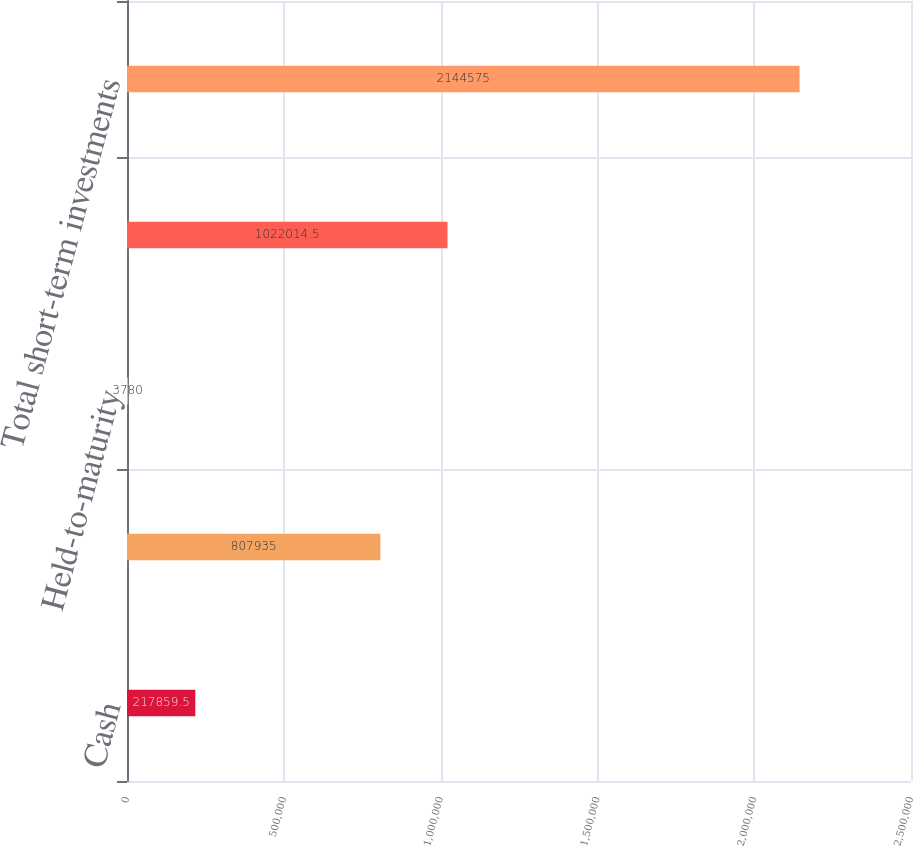Convert chart. <chart><loc_0><loc_0><loc_500><loc_500><bar_chart><fcel>Cash<fcel>Available-for-sale<fcel>Held-to-maturity<fcel>Total cash and cash<fcel>Total short-term investments<nl><fcel>217860<fcel>807935<fcel>3780<fcel>1.02201e+06<fcel>2.14458e+06<nl></chart> 